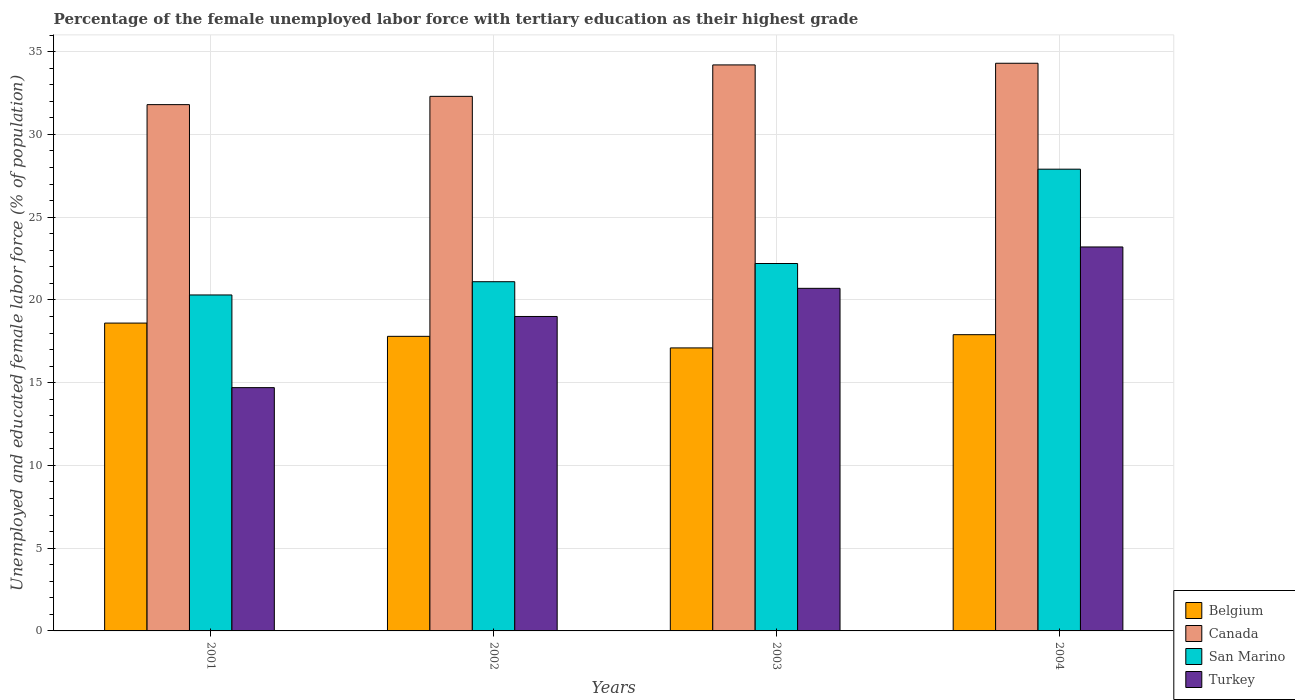How many different coloured bars are there?
Offer a very short reply. 4. Are the number of bars on each tick of the X-axis equal?
Provide a succinct answer. Yes. How many bars are there on the 3rd tick from the left?
Provide a short and direct response. 4. How many bars are there on the 3rd tick from the right?
Make the answer very short. 4. In how many cases, is the number of bars for a given year not equal to the number of legend labels?
Ensure brevity in your answer.  0. What is the percentage of the unemployed female labor force with tertiary education in Turkey in 2004?
Your answer should be very brief. 23.2. Across all years, what is the maximum percentage of the unemployed female labor force with tertiary education in Turkey?
Your response must be concise. 23.2. Across all years, what is the minimum percentage of the unemployed female labor force with tertiary education in Belgium?
Provide a succinct answer. 17.1. In which year was the percentage of the unemployed female labor force with tertiary education in Canada minimum?
Provide a short and direct response. 2001. What is the total percentage of the unemployed female labor force with tertiary education in Canada in the graph?
Your response must be concise. 132.6. What is the difference between the percentage of the unemployed female labor force with tertiary education in Belgium in 2002 and that in 2003?
Ensure brevity in your answer.  0.7. What is the difference between the percentage of the unemployed female labor force with tertiary education in Turkey in 2003 and the percentage of the unemployed female labor force with tertiary education in Belgium in 2001?
Give a very brief answer. 2.1. What is the average percentage of the unemployed female labor force with tertiary education in San Marino per year?
Give a very brief answer. 22.88. In the year 2001, what is the difference between the percentage of the unemployed female labor force with tertiary education in Belgium and percentage of the unemployed female labor force with tertiary education in San Marino?
Provide a succinct answer. -1.7. In how many years, is the percentage of the unemployed female labor force with tertiary education in Canada greater than 11 %?
Offer a very short reply. 4. What is the ratio of the percentage of the unemployed female labor force with tertiary education in Turkey in 2001 to that in 2002?
Ensure brevity in your answer.  0.77. Is the difference between the percentage of the unemployed female labor force with tertiary education in Belgium in 2001 and 2003 greater than the difference between the percentage of the unemployed female labor force with tertiary education in San Marino in 2001 and 2003?
Offer a very short reply. Yes. What is the difference between the highest and the second highest percentage of the unemployed female labor force with tertiary education in Turkey?
Ensure brevity in your answer.  2.5. What is the difference between the highest and the lowest percentage of the unemployed female labor force with tertiary education in Turkey?
Make the answer very short. 8.5. Is it the case that in every year, the sum of the percentage of the unemployed female labor force with tertiary education in Belgium and percentage of the unemployed female labor force with tertiary education in Canada is greater than the sum of percentage of the unemployed female labor force with tertiary education in San Marino and percentage of the unemployed female labor force with tertiary education in Turkey?
Offer a terse response. Yes. What does the 3rd bar from the right in 2001 represents?
Keep it short and to the point. Canada. How many bars are there?
Provide a short and direct response. 16. What is the difference between two consecutive major ticks on the Y-axis?
Offer a very short reply. 5. Are the values on the major ticks of Y-axis written in scientific E-notation?
Your answer should be very brief. No. Does the graph contain any zero values?
Make the answer very short. No. How many legend labels are there?
Offer a very short reply. 4. How are the legend labels stacked?
Offer a terse response. Vertical. What is the title of the graph?
Provide a short and direct response. Percentage of the female unemployed labor force with tertiary education as their highest grade. Does "Vietnam" appear as one of the legend labels in the graph?
Offer a very short reply. No. What is the label or title of the X-axis?
Keep it short and to the point. Years. What is the label or title of the Y-axis?
Offer a terse response. Unemployed and educated female labor force (% of population). What is the Unemployed and educated female labor force (% of population) in Belgium in 2001?
Give a very brief answer. 18.6. What is the Unemployed and educated female labor force (% of population) in Canada in 2001?
Give a very brief answer. 31.8. What is the Unemployed and educated female labor force (% of population) of San Marino in 2001?
Keep it short and to the point. 20.3. What is the Unemployed and educated female labor force (% of population) of Turkey in 2001?
Offer a very short reply. 14.7. What is the Unemployed and educated female labor force (% of population) of Belgium in 2002?
Provide a short and direct response. 17.8. What is the Unemployed and educated female labor force (% of population) of Canada in 2002?
Offer a very short reply. 32.3. What is the Unemployed and educated female labor force (% of population) in San Marino in 2002?
Provide a succinct answer. 21.1. What is the Unemployed and educated female labor force (% of population) in Turkey in 2002?
Keep it short and to the point. 19. What is the Unemployed and educated female labor force (% of population) in Belgium in 2003?
Offer a terse response. 17.1. What is the Unemployed and educated female labor force (% of population) of Canada in 2003?
Provide a short and direct response. 34.2. What is the Unemployed and educated female labor force (% of population) in San Marino in 2003?
Give a very brief answer. 22.2. What is the Unemployed and educated female labor force (% of population) in Turkey in 2003?
Give a very brief answer. 20.7. What is the Unemployed and educated female labor force (% of population) in Belgium in 2004?
Ensure brevity in your answer.  17.9. What is the Unemployed and educated female labor force (% of population) of Canada in 2004?
Offer a very short reply. 34.3. What is the Unemployed and educated female labor force (% of population) in San Marino in 2004?
Your answer should be compact. 27.9. What is the Unemployed and educated female labor force (% of population) in Turkey in 2004?
Make the answer very short. 23.2. Across all years, what is the maximum Unemployed and educated female labor force (% of population) of Belgium?
Your answer should be very brief. 18.6. Across all years, what is the maximum Unemployed and educated female labor force (% of population) in Canada?
Provide a short and direct response. 34.3. Across all years, what is the maximum Unemployed and educated female labor force (% of population) of San Marino?
Keep it short and to the point. 27.9. Across all years, what is the maximum Unemployed and educated female labor force (% of population) of Turkey?
Offer a very short reply. 23.2. Across all years, what is the minimum Unemployed and educated female labor force (% of population) in Belgium?
Keep it short and to the point. 17.1. Across all years, what is the minimum Unemployed and educated female labor force (% of population) in Canada?
Your response must be concise. 31.8. Across all years, what is the minimum Unemployed and educated female labor force (% of population) of San Marino?
Keep it short and to the point. 20.3. Across all years, what is the minimum Unemployed and educated female labor force (% of population) of Turkey?
Provide a short and direct response. 14.7. What is the total Unemployed and educated female labor force (% of population) of Belgium in the graph?
Your answer should be compact. 71.4. What is the total Unemployed and educated female labor force (% of population) in Canada in the graph?
Your answer should be compact. 132.6. What is the total Unemployed and educated female labor force (% of population) of San Marino in the graph?
Make the answer very short. 91.5. What is the total Unemployed and educated female labor force (% of population) of Turkey in the graph?
Your response must be concise. 77.6. What is the difference between the Unemployed and educated female labor force (% of population) of Belgium in 2001 and that in 2002?
Your response must be concise. 0.8. What is the difference between the Unemployed and educated female labor force (% of population) in Canada in 2001 and that in 2002?
Make the answer very short. -0.5. What is the difference between the Unemployed and educated female labor force (% of population) in San Marino in 2001 and that in 2002?
Provide a succinct answer. -0.8. What is the difference between the Unemployed and educated female labor force (% of population) in Turkey in 2001 and that in 2002?
Give a very brief answer. -4.3. What is the difference between the Unemployed and educated female labor force (% of population) in Belgium in 2001 and that in 2003?
Your answer should be compact. 1.5. What is the difference between the Unemployed and educated female labor force (% of population) in Turkey in 2001 and that in 2003?
Ensure brevity in your answer.  -6. What is the difference between the Unemployed and educated female labor force (% of population) of Belgium in 2001 and that in 2004?
Keep it short and to the point. 0.7. What is the difference between the Unemployed and educated female labor force (% of population) of Belgium in 2002 and that in 2003?
Your answer should be very brief. 0.7. What is the difference between the Unemployed and educated female labor force (% of population) of Turkey in 2002 and that in 2003?
Your response must be concise. -1.7. What is the difference between the Unemployed and educated female labor force (% of population) in Belgium in 2002 and that in 2004?
Keep it short and to the point. -0.1. What is the difference between the Unemployed and educated female labor force (% of population) in San Marino in 2002 and that in 2004?
Your answer should be compact. -6.8. What is the difference between the Unemployed and educated female labor force (% of population) of Turkey in 2002 and that in 2004?
Give a very brief answer. -4.2. What is the difference between the Unemployed and educated female labor force (% of population) of Belgium in 2003 and that in 2004?
Provide a short and direct response. -0.8. What is the difference between the Unemployed and educated female labor force (% of population) of San Marino in 2003 and that in 2004?
Offer a very short reply. -5.7. What is the difference between the Unemployed and educated female labor force (% of population) of Belgium in 2001 and the Unemployed and educated female labor force (% of population) of Canada in 2002?
Provide a short and direct response. -13.7. What is the difference between the Unemployed and educated female labor force (% of population) of Canada in 2001 and the Unemployed and educated female labor force (% of population) of San Marino in 2002?
Your answer should be compact. 10.7. What is the difference between the Unemployed and educated female labor force (% of population) of San Marino in 2001 and the Unemployed and educated female labor force (% of population) of Turkey in 2002?
Provide a succinct answer. 1.3. What is the difference between the Unemployed and educated female labor force (% of population) of Belgium in 2001 and the Unemployed and educated female labor force (% of population) of Canada in 2003?
Your answer should be very brief. -15.6. What is the difference between the Unemployed and educated female labor force (% of population) of Belgium in 2001 and the Unemployed and educated female labor force (% of population) of San Marino in 2003?
Your answer should be compact. -3.6. What is the difference between the Unemployed and educated female labor force (% of population) of Belgium in 2001 and the Unemployed and educated female labor force (% of population) of Turkey in 2003?
Offer a terse response. -2.1. What is the difference between the Unemployed and educated female labor force (% of population) in Canada in 2001 and the Unemployed and educated female labor force (% of population) in San Marino in 2003?
Make the answer very short. 9.6. What is the difference between the Unemployed and educated female labor force (% of population) in Canada in 2001 and the Unemployed and educated female labor force (% of population) in Turkey in 2003?
Provide a short and direct response. 11.1. What is the difference between the Unemployed and educated female labor force (% of population) of Belgium in 2001 and the Unemployed and educated female labor force (% of population) of Canada in 2004?
Your answer should be compact. -15.7. What is the difference between the Unemployed and educated female labor force (% of population) of Belgium in 2001 and the Unemployed and educated female labor force (% of population) of San Marino in 2004?
Ensure brevity in your answer.  -9.3. What is the difference between the Unemployed and educated female labor force (% of population) in Canada in 2001 and the Unemployed and educated female labor force (% of population) in San Marino in 2004?
Offer a very short reply. 3.9. What is the difference between the Unemployed and educated female labor force (% of population) in Canada in 2001 and the Unemployed and educated female labor force (% of population) in Turkey in 2004?
Your answer should be compact. 8.6. What is the difference between the Unemployed and educated female labor force (% of population) in Belgium in 2002 and the Unemployed and educated female labor force (% of population) in Canada in 2003?
Provide a short and direct response. -16.4. What is the difference between the Unemployed and educated female labor force (% of population) of Belgium in 2002 and the Unemployed and educated female labor force (% of population) of San Marino in 2003?
Make the answer very short. -4.4. What is the difference between the Unemployed and educated female labor force (% of population) in Belgium in 2002 and the Unemployed and educated female labor force (% of population) in Turkey in 2003?
Ensure brevity in your answer.  -2.9. What is the difference between the Unemployed and educated female labor force (% of population) of Canada in 2002 and the Unemployed and educated female labor force (% of population) of San Marino in 2003?
Provide a short and direct response. 10.1. What is the difference between the Unemployed and educated female labor force (% of population) of Canada in 2002 and the Unemployed and educated female labor force (% of population) of Turkey in 2003?
Your answer should be very brief. 11.6. What is the difference between the Unemployed and educated female labor force (% of population) in Belgium in 2002 and the Unemployed and educated female labor force (% of population) in Canada in 2004?
Keep it short and to the point. -16.5. What is the difference between the Unemployed and educated female labor force (% of population) in Belgium in 2002 and the Unemployed and educated female labor force (% of population) in San Marino in 2004?
Offer a terse response. -10.1. What is the difference between the Unemployed and educated female labor force (% of population) in Belgium in 2002 and the Unemployed and educated female labor force (% of population) in Turkey in 2004?
Your answer should be very brief. -5.4. What is the difference between the Unemployed and educated female labor force (% of population) in Canada in 2002 and the Unemployed and educated female labor force (% of population) in San Marino in 2004?
Your response must be concise. 4.4. What is the difference between the Unemployed and educated female labor force (% of population) of Canada in 2002 and the Unemployed and educated female labor force (% of population) of Turkey in 2004?
Offer a terse response. 9.1. What is the difference between the Unemployed and educated female labor force (% of population) in San Marino in 2002 and the Unemployed and educated female labor force (% of population) in Turkey in 2004?
Offer a terse response. -2.1. What is the difference between the Unemployed and educated female labor force (% of population) in Belgium in 2003 and the Unemployed and educated female labor force (% of population) in Canada in 2004?
Offer a very short reply. -17.2. What is the difference between the Unemployed and educated female labor force (% of population) in Canada in 2003 and the Unemployed and educated female labor force (% of population) in Turkey in 2004?
Ensure brevity in your answer.  11. What is the difference between the Unemployed and educated female labor force (% of population) of San Marino in 2003 and the Unemployed and educated female labor force (% of population) of Turkey in 2004?
Your answer should be compact. -1. What is the average Unemployed and educated female labor force (% of population) in Belgium per year?
Make the answer very short. 17.85. What is the average Unemployed and educated female labor force (% of population) in Canada per year?
Offer a terse response. 33.15. What is the average Unemployed and educated female labor force (% of population) of San Marino per year?
Your answer should be very brief. 22.88. In the year 2001, what is the difference between the Unemployed and educated female labor force (% of population) of Belgium and Unemployed and educated female labor force (% of population) of Canada?
Keep it short and to the point. -13.2. In the year 2001, what is the difference between the Unemployed and educated female labor force (% of population) of Belgium and Unemployed and educated female labor force (% of population) of Turkey?
Ensure brevity in your answer.  3.9. In the year 2001, what is the difference between the Unemployed and educated female labor force (% of population) of Canada and Unemployed and educated female labor force (% of population) of San Marino?
Offer a very short reply. 11.5. In the year 2001, what is the difference between the Unemployed and educated female labor force (% of population) of Canada and Unemployed and educated female labor force (% of population) of Turkey?
Your answer should be compact. 17.1. In the year 2002, what is the difference between the Unemployed and educated female labor force (% of population) in Belgium and Unemployed and educated female labor force (% of population) in Turkey?
Make the answer very short. -1.2. In the year 2002, what is the difference between the Unemployed and educated female labor force (% of population) of Canada and Unemployed and educated female labor force (% of population) of Turkey?
Provide a short and direct response. 13.3. In the year 2002, what is the difference between the Unemployed and educated female labor force (% of population) in San Marino and Unemployed and educated female labor force (% of population) in Turkey?
Give a very brief answer. 2.1. In the year 2003, what is the difference between the Unemployed and educated female labor force (% of population) in Belgium and Unemployed and educated female labor force (% of population) in Canada?
Make the answer very short. -17.1. In the year 2003, what is the difference between the Unemployed and educated female labor force (% of population) of Belgium and Unemployed and educated female labor force (% of population) of San Marino?
Your response must be concise. -5.1. In the year 2003, what is the difference between the Unemployed and educated female labor force (% of population) in Canada and Unemployed and educated female labor force (% of population) in Turkey?
Provide a short and direct response. 13.5. In the year 2004, what is the difference between the Unemployed and educated female labor force (% of population) in Belgium and Unemployed and educated female labor force (% of population) in Canada?
Your response must be concise. -16.4. In the year 2004, what is the difference between the Unemployed and educated female labor force (% of population) in Belgium and Unemployed and educated female labor force (% of population) in San Marino?
Your response must be concise. -10. In the year 2004, what is the difference between the Unemployed and educated female labor force (% of population) in Belgium and Unemployed and educated female labor force (% of population) in Turkey?
Ensure brevity in your answer.  -5.3. In the year 2004, what is the difference between the Unemployed and educated female labor force (% of population) of Canada and Unemployed and educated female labor force (% of population) of Turkey?
Your answer should be compact. 11.1. In the year 2004, what is the difference between the Unemployed and educated female labor force (% of population) of San Marino and Unemployed and educated female labor force (% of population) of Turkey?
Provide a short and direct response. 4.7. What is the ratio of the Unemployed and educated female labor force (% of population) in Belgium in 2001 to that in 2002?
Ensure brevity in your answer.  1.04. What is the ratio of the Unemployed and educated female labor force (% of population) in Canada in 2001 to that in 2002?
Ensure brevity in your answer.  0.98. What is the ratio of the Unemployed and educated female labor force (% of population) in San Marino in 2001 to that in 2002?
Make the answer very short. 0.96. What is the ratio of the Unemployed and educated female labor force (% of population) of Turkey in 2001 to that in 2002?
Offer a terse response. 0.77. What is the ratio of the Unemployed and educated female labor force (% of population) in Belgium in 2001 to that in 2003?
Ensure brevity in your answer.  1.09. What is the ratio of the Unemployed and educated female labor force (% of population) of Canada in 2001 to that in 2003?
Make the answer very short. 0.93. What is the ratio of the Unemployed and educated female labor force (% of population) in San Marino in 2001 to that in 2003?
Your answer should be very brief. 0.91. What is the ratio of the Unemployed and educated female labor force (% of population) in Turkey in 2001 to that in 2003?
Offer a terse response. 0.71. What is the ratio of the Unemployed and educated female labor force (% of population) in Belgium in 2001 to that in 2004?
Keep it short and to the point. 1.04. What is the ratio of the Unemployed and educated female labor force (% of population) in Canada in 2001 to that in 2004?
Offer a very short reply. 0.93. What is the ratio of the Unemployed and educated female labor force (% of population) in San Marino in 2001 to that in 2004?
Your answer should be very brief. 0.73. What is the ratio of the Unemployed and educated female labor force (% of population) in Turkey in 2001 to that in 2004?
Provide a succinct answer. 0.63. What is the ratio of the Unemployed and educated female labor force (% of population) in Belgium in 2002 to that in 2003?
Your response must be concise. 1.04. What is the ratio of the Unemployed and educated female labor force (% of population) of Canada in 2002 to that in 2003?
Offer a very short reply. 0.94. What is the ratio of the Unemployed and educated female labor force (% of population) in San Marino in 2002 to that in 2003?
Provide a succinct answer. 0.95. What is the ratio of the Unemployed and educated female labor force (% of population) in Turkey in 2002 to that in 2003?
Your answer should be compact. 0.92. What is the ratio of the Unemployed and educated female labor force (% of population) of Canada in 2002 to that in 2004?
Give a very brief answer. 0.94. What is the ratio of the Unemployed and educated female labor force (% of population) of San Marino in 2002 to that in 2004?
Make the answer very short. 0.76. What is the ratio of the Unemployed and educated female labor force (% of population) in Turkey in 2002 to that in 2004?
Offer a very short reply. 0.82. What is the ratio of the Unemployed and educated female labor force (% of population) in Belgium in 2003 to that in 2004?
Your answer should be very brief. 0.96. What is the ratio of the Unemployed and educated female labor force (% of population) of Canada in 2003 to that in 2004?
Make the answer very short. 1. What is the ratio of the Unemployed and educated female labor force (% of population) in San Marino in 2003 to that in 2004?
Ensure brevity in your answer.  0.8. What is the ratio of the Unemployed and educated female labor force (% of population) in Turkey in 2003 to that in 2004?
Your response must be concise. 0.89. What is the difference between the highest and the second highest Unemployed and educated female labor force (% of population) in Belgium?
Your answer should be compact. 0.7. What is the difference between the highest and the second highest Unemployed and educated female labor force (% of population) in Canada?
Provide a succinct answer. 0.1. What is the difference between the highest and the lowest Unemployed and educated female labor force (% of population) of Turkey?
Offer a terse response. 8.5. 